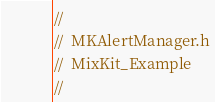Convert code to text. <code><loc_0><loc_0><loc_500><loc_500><_C_>//
//  MKAlertManager.h
//  MixKit_Example
//</code> 